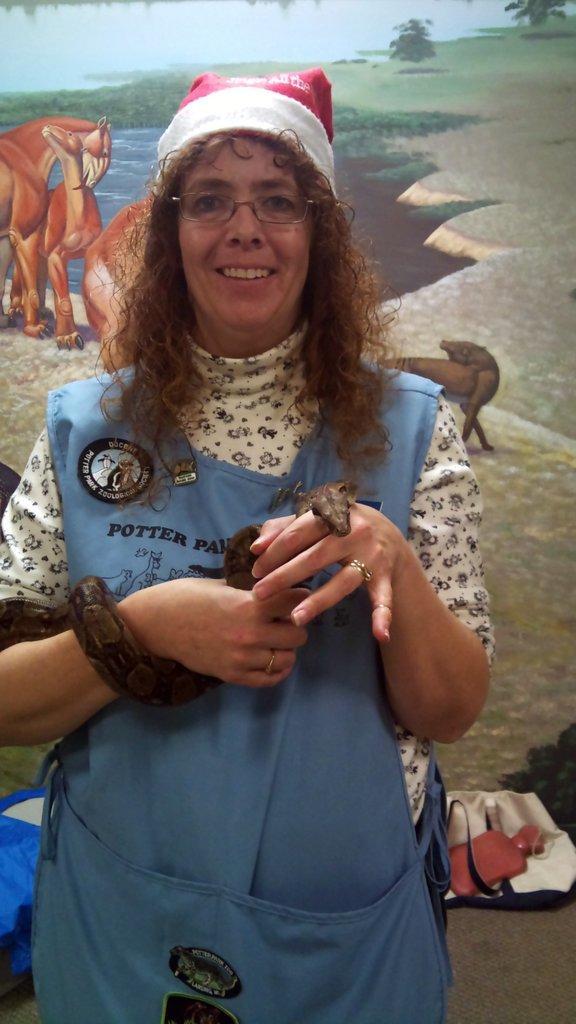Can you describe this image briefly? In the middle of the image a woman is standing and smiling and holding a snake. Behind her there is a wall, on the wall we can see a painting. 